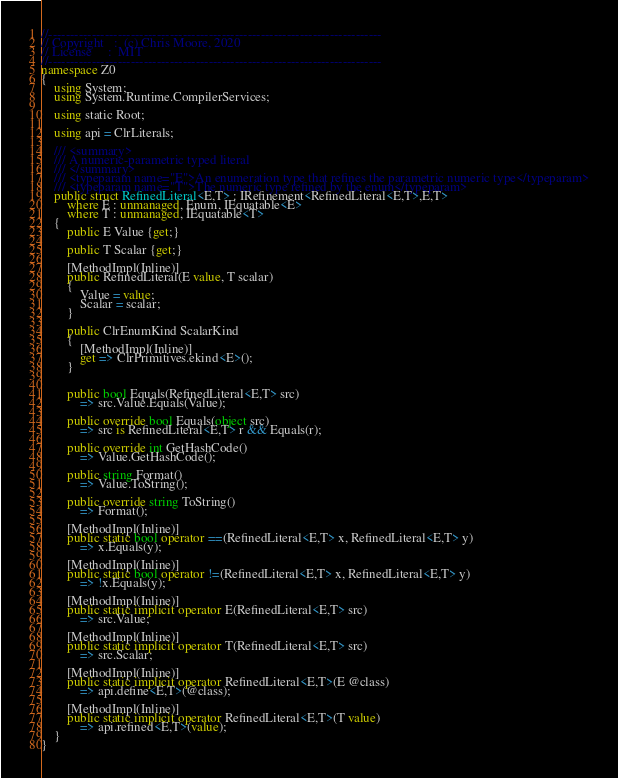Convert code to text. <code><loc_0><loc_0><loc_500><loc_500><_C#_>//-----------------------------------------------------------------------------
// Copyright   :  (c) Chris Moore, 2020
// License     :  MIT
//-----------------------------------------------------------------------------
namespace Z0
{
    using System;
    using System.Runtime.CompilerServices;

    using static Root;

    using api = ClrLiterals;

    /// <summary>
    /// A numeric-parametric typed literal
    /// </summary>
    /// <typeparam name="E">An enumeration type that refines the parametric numeric type</typeparam>
    /// <typeparam name="T">The numeric type refined by the enum</typeparam>
    public struct RefinedLiteral<E,T> : IRefinement<RefinedLiteral<E,T>,E,T>
        where E : unmanaged, Enum, IEquatable<E>
        where T : unmanaged, IEquatable<T>
    {
        public E Value {get;}

        public T Scalar {get;}

        [MethodImpl(Inline)]
        public RefinedLiteral(E value, T scalar)
        {
            Value = value;
            Scalar = scalar;
        }

        public ClrEnumKind ScalarKind
        {
            [MethodImpl(Inline)]
            get => ClrPrimitives.ekind<E>();
        }


        public bool Equals(RefinedLiteral<E,T> src)
            => src.Value.Equals(Value);

        public override bool Equals(object src)
            => src is RefinedLiteral<E,T> r && Equals(r);

        public override int GetHashCode()
            => Value.GetHashCode();

        public string Format()
            => Value.ToString();

        public override string ToString()
            => Format();

        [MethodImpl(Inline)]
        public static bool operator ==(RefinedLiteral<E,T> x, RefinedLiteral<E,T> y)
            => x.Equals(y);

        [MethodImpl(Inline)]
        public static bool operator !=(RefinedLiteral<E,T> x, RefinedLiteral<E,T> y)
            => !x.Equals(y);

        [MethodImpl(Inline)]
        public static implicit operator E(RefinedLiteral<E,T> src)
            => src.Value;

        [MethodImpl(Inline)]
        public static implicit operator T(RefinedLiteral<E,T> src)
            => src.Scalar;

        [MethodImpl(Inline)]
        public static implicit operator RefinedLiteral<E,T>(E @class)
            => api.define<E,T>(@class);

        [MethodImpl(Inline)]
        public static implicit operator RefinedLiteral<E,T>(T value)
            => api.refined<E,T>(value);
    }
}</code> 